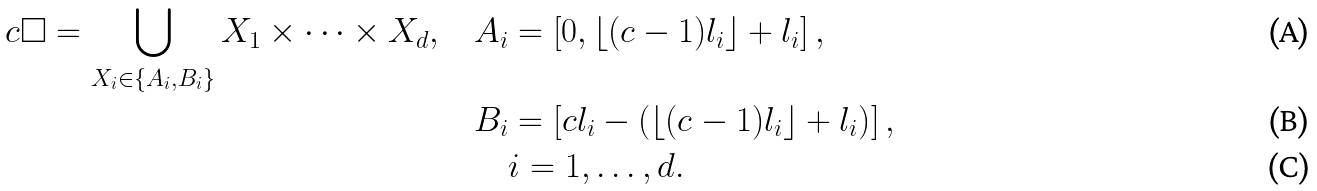Convert formula to latex. <formula><loc_0><loc_0><loc_500><loc_500>c \Box = \bigcup _ { X _ { i } \in \{ A _ { i } , B _ { i } \} } X _ { 1 } \times \cdots \times X _ { d } , \quad & A _ { i } = \left [ 0 , \lfloor ( c - 1 ) l _ { i } \rfloor + l _ { i } \right ] , \\ & B _ { i } = \left [ c l _ { i } - \left ( \lfloor ( c - 1 ) l _ { i } \rfloor + l _ { i } \right ) \right ] , \\ & \quad i = 1 , \dots , d .</formula> 